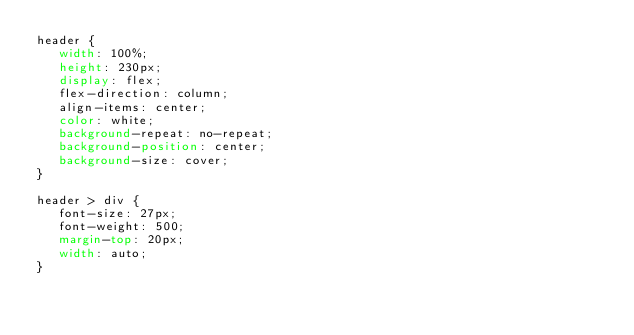Convert code to text. <code><loc_0><loc_0><loc_500><loc_500><_CSS_>header {
   width: 100%;
   height: 230px;
   display: flex;
   flex-direction: column;
   align-items: center;
   color: white;
   background-repeat: no-repeat;
   background-position: center;
   background-size: cover;
}

header > div {
   font-size: 27px;
   font-weight: 500;
   margin-top: 20px;
   width: auto;
}
</code> 